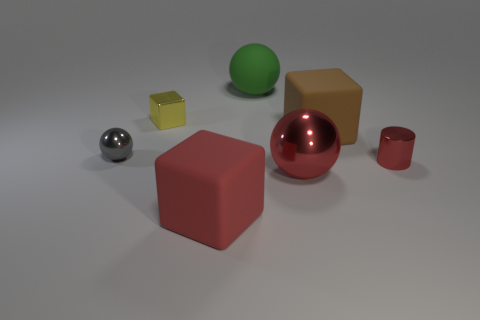Is the number of large things on the right side of the green matte sphere greater than the number of cylinders that are behind the big red metal thing?
Give a very brief answer. Yes. How many other objects are the same size as the gray metal object?
Give a very brief answer. 2. The small object that is both in front of the yellow shiny block and left of the green ball is made of what material?
Your answer should be very brief. Metal. There is another small object that is the same shape as the red rubber thing; what is it made of?
Offer a very short reply. Metal. There is a ball that is in front of the tiny object that is left of the tiny block; how many objects are left of it?
Make the answer very short. 4. Is there anything else that has the same color as the cylinder?
Offer a terse response. Yes. What number of metal objects are both behind the big red metal object and left of the small red metal cylinder?
Ensure brevity in your answer.  2. Do the rubber object in front of the tiny gray ball and the ball that is left of the rubber ball have the same size?
Ensure brevity in your answer.  No. What number of things are either shiny balls that are right of the gray metallic thing or tiny gray metallic balls?
Provide a succinct answer. 2. What is the material of the block that is in front of the small sphere?
Give a very brief answer. Rubber. 